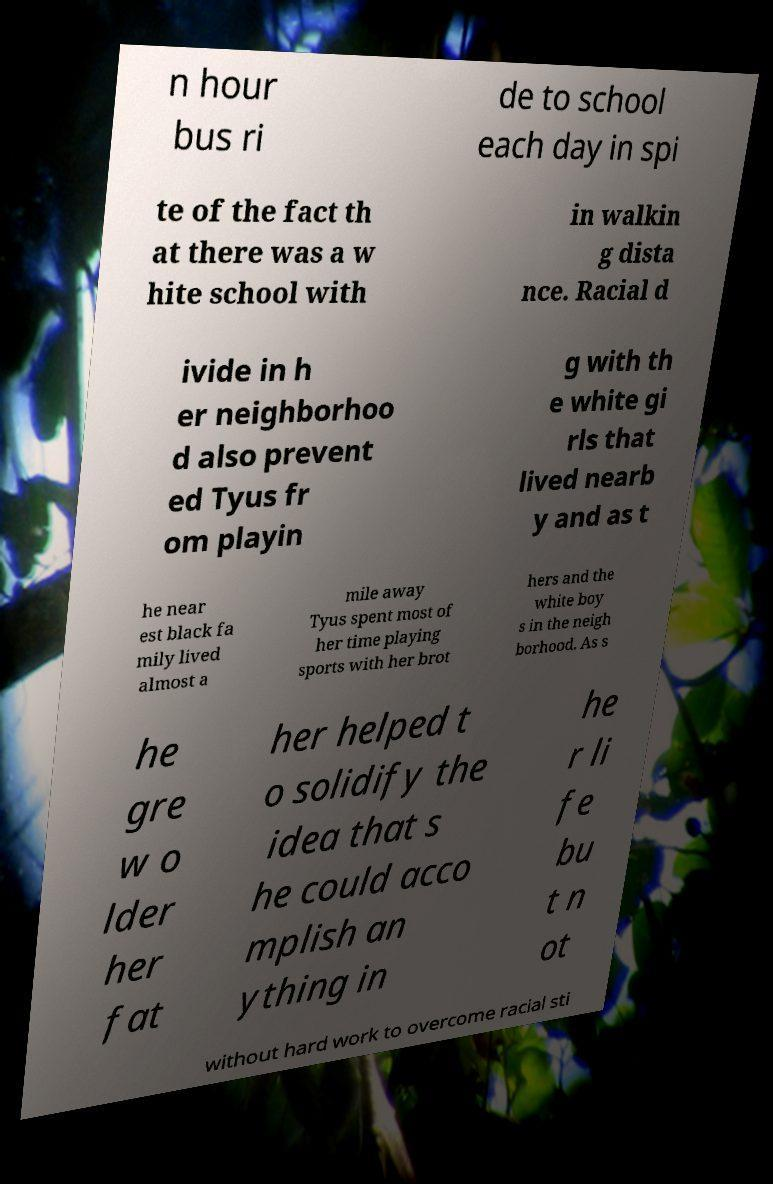Please read and relay the text visible in this image. What does it say? n hour bus ri de to school each day in spi te of the fact th at there was a w hite school with in walkin g dista nce. Racial d ivide in h er neighborhoo d also prevent ed Tyus fr om playin g with th e white gi rls that lived nearb y and as t he near est black fa mily lived almost a mile away Tyus spent most of her time playing sports with her brot hers and the white boy s in the neigh borhood. As s he gre w o lder her fat her helped t o solidify the idea that s he could acco mplish an ything in he r li fe bu t n ot without hard work to overcome racial sti 